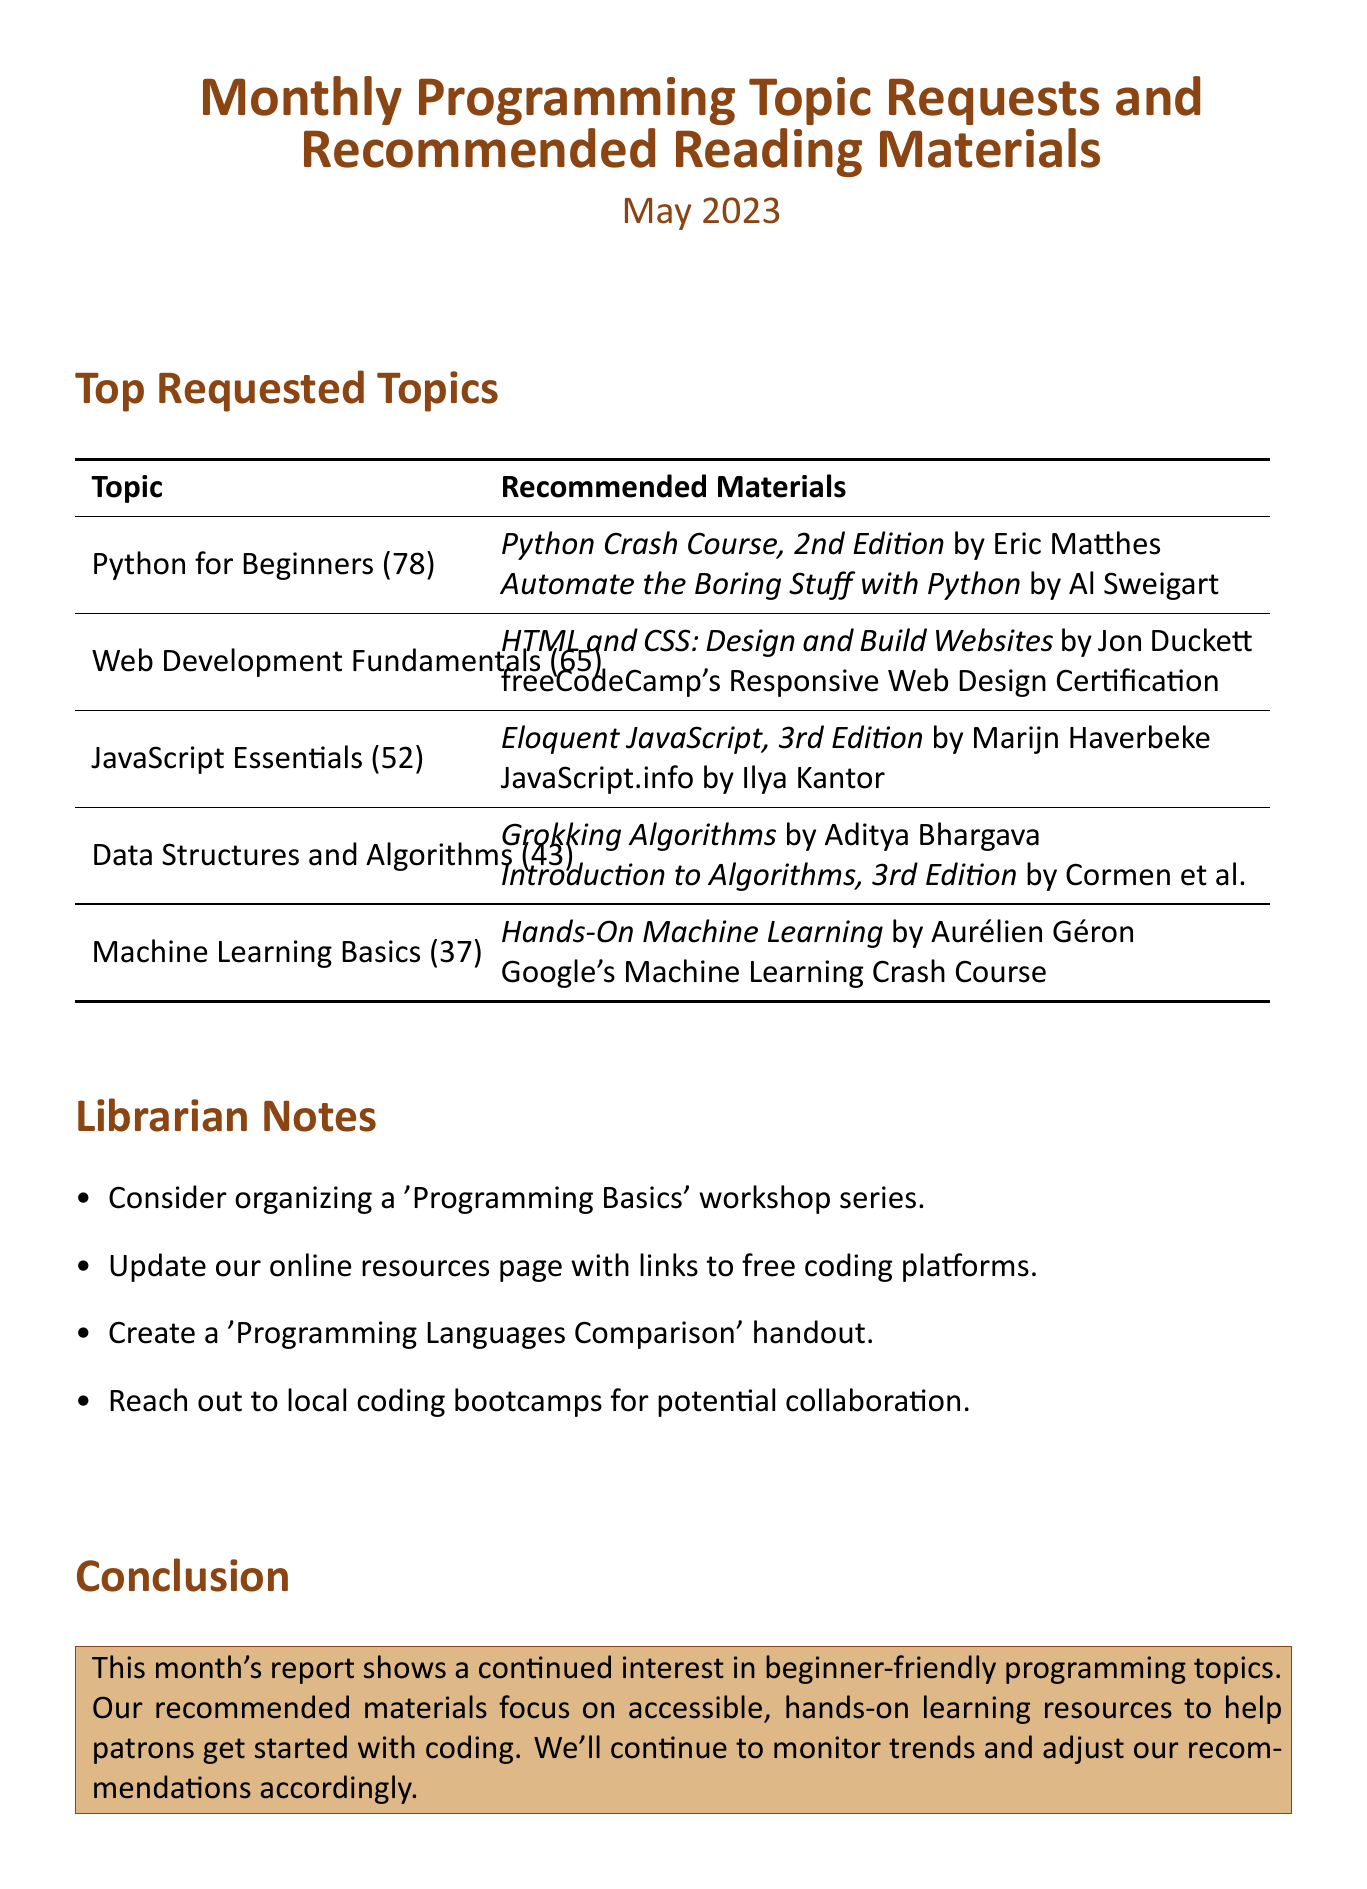What is the title of the report? The title of the report is stated at the beginning of the document.
Answer: Monthly Programming Topic Requests and Recommended Reading Materials How many times was "Python for Beginners" requested? The frequency of requests for each topic is listed in parentheses next to the topic.
Answer: 78 Who is the author of "Grokking Algorithms"? The document lists the authors of the recommended materials next to each title.
Answer: Aditya Bhargava What is one recommended online resource for "Machine Learning Basics"? The recommended materials include both books and online resources for each topic.
Answer: Machine Learning Crash Course Which topic had the second highest frequency of requests? The topics are ordered by frequency, and this question asks for the second one in the list.
Answer: Web Development Fundamentals What suggestion is made for library workshops? The librarian notes include specific suggestions for workshops or events based on patron requests.
Answer: Organizing a 'Programming Basics' workshop series What is a proposed update for online resources? The librarian notes provide ideas for improving the library's resources and services.
Answer: Update our online resources page with links to free coding platforms Which course covers HTML and CSS? The recommendations for Web Development Fundamentals include various resources, including courses.
Answer: freeCodeCamp's Responsive Web Design Certification How many requested topics are listed in the report? The document specifies the number of requested topics covered in the top requested topics section.
Answer: Five 